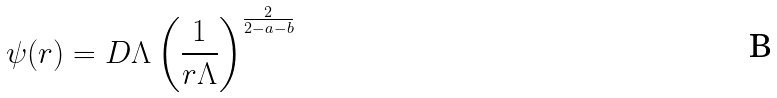<formula> <loc_0><loc_0><loc_500><loc_500>\psi ( r ) = D \Lambda \left ( \frac { 1 } { r \Lambda } \right ) ^ { \frac { 2 } { 2 - a - b } }</formula> 